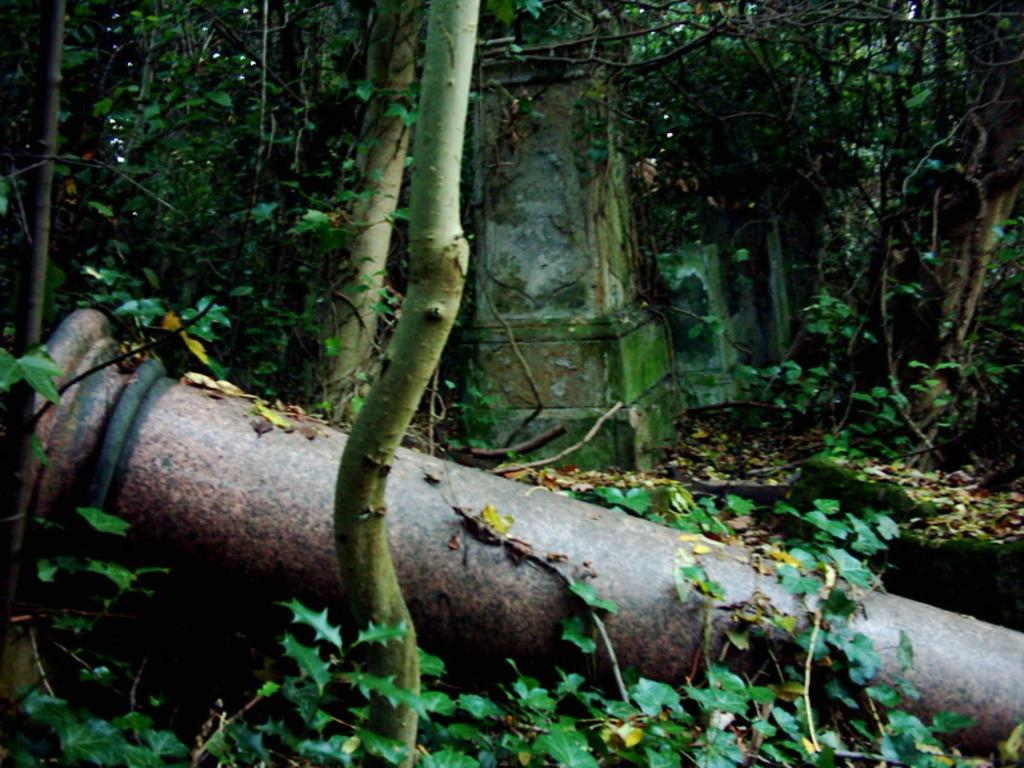What event has occurred in the image involving a pillar? A pillar has fallen on the ground in the image. What other objects can be seen in the image besides the fallen pillar? There are plants and more pillars visible in the image. What type of vegetation is present in the background of the image? There are trees in the background of the image. What type of pancake is being served at the zoo in the image? There is no zoo or pancake present in the image; it features a fallen pillar and other architectural elements. 